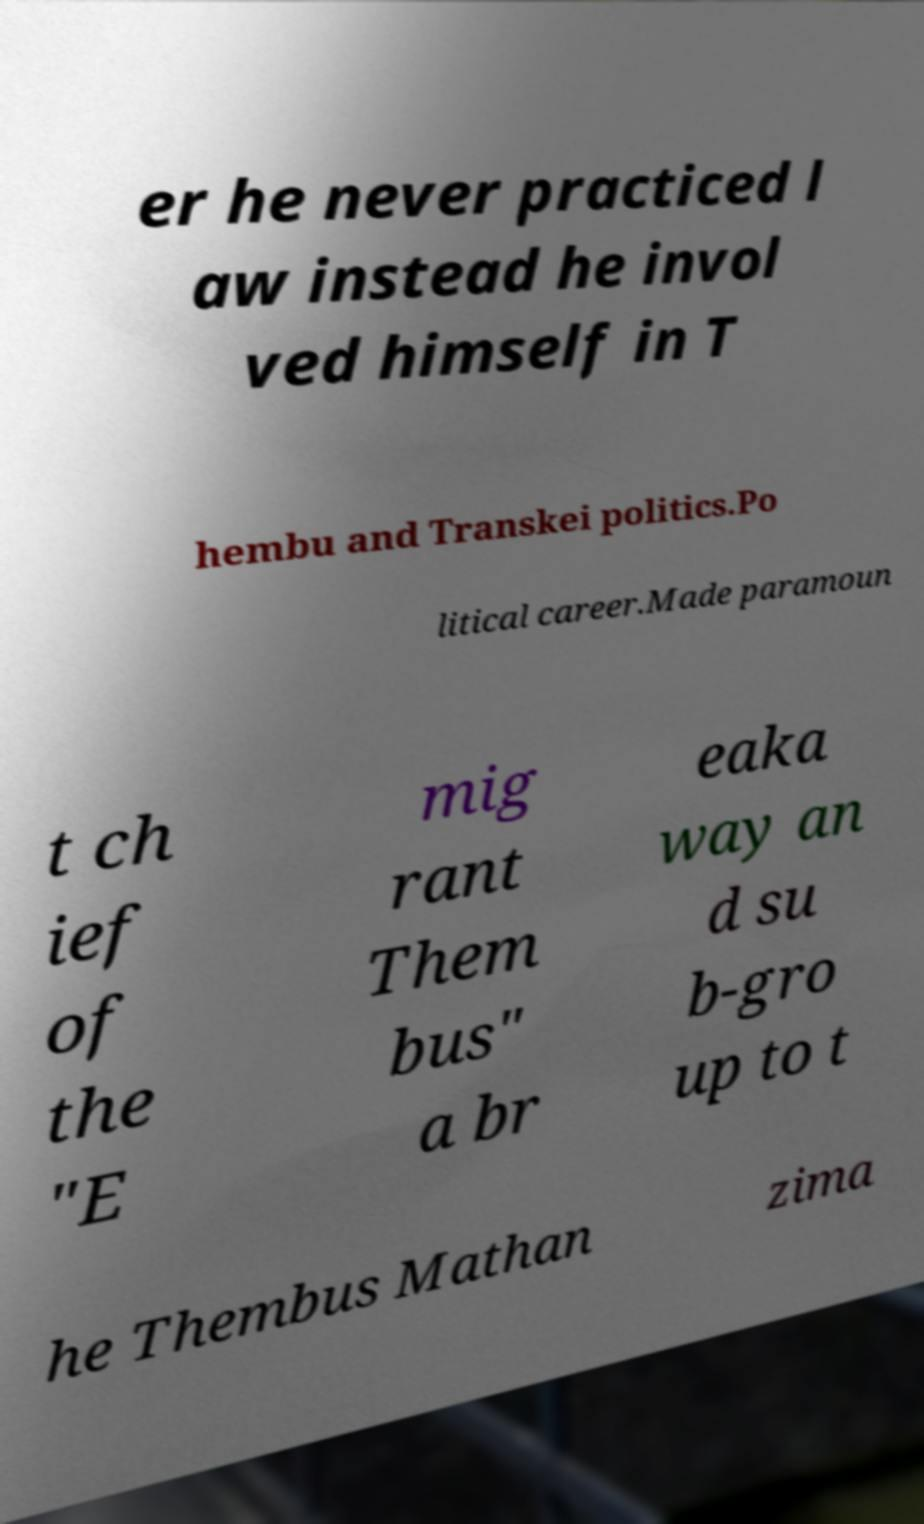Could you extract and type out the text from this image? er he never practiced l aw instead he invol ved himself in T hembu and Transkei politics.Po litical career.Made paramoun t ch ief of the "E mig rant Them bus" a br eaka way an d su b-gro up to t he Thembus Mathan zima 